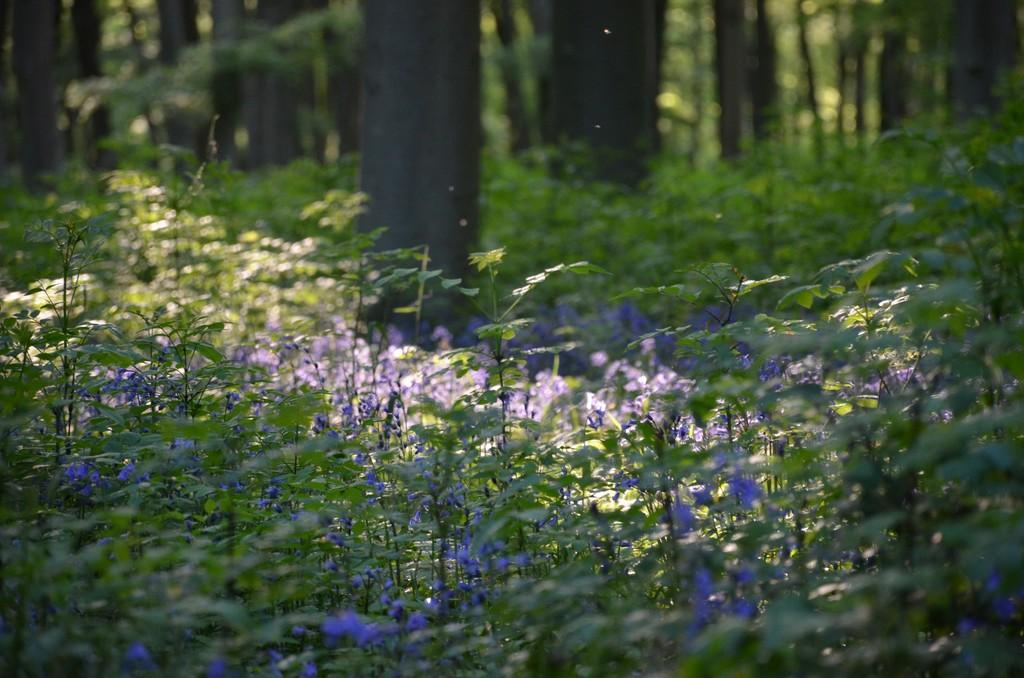What type of plants can be seen in the image? There are plants with flowers in the image. Can you describe any other features of the plants? The bark of trees is visible on the backside of the image. Can you see any signs of war in the image? There is no indication of war in the image; it features plants with flowers and tree bark. Is there a swing present in the image? There is no swing visible in the image. 